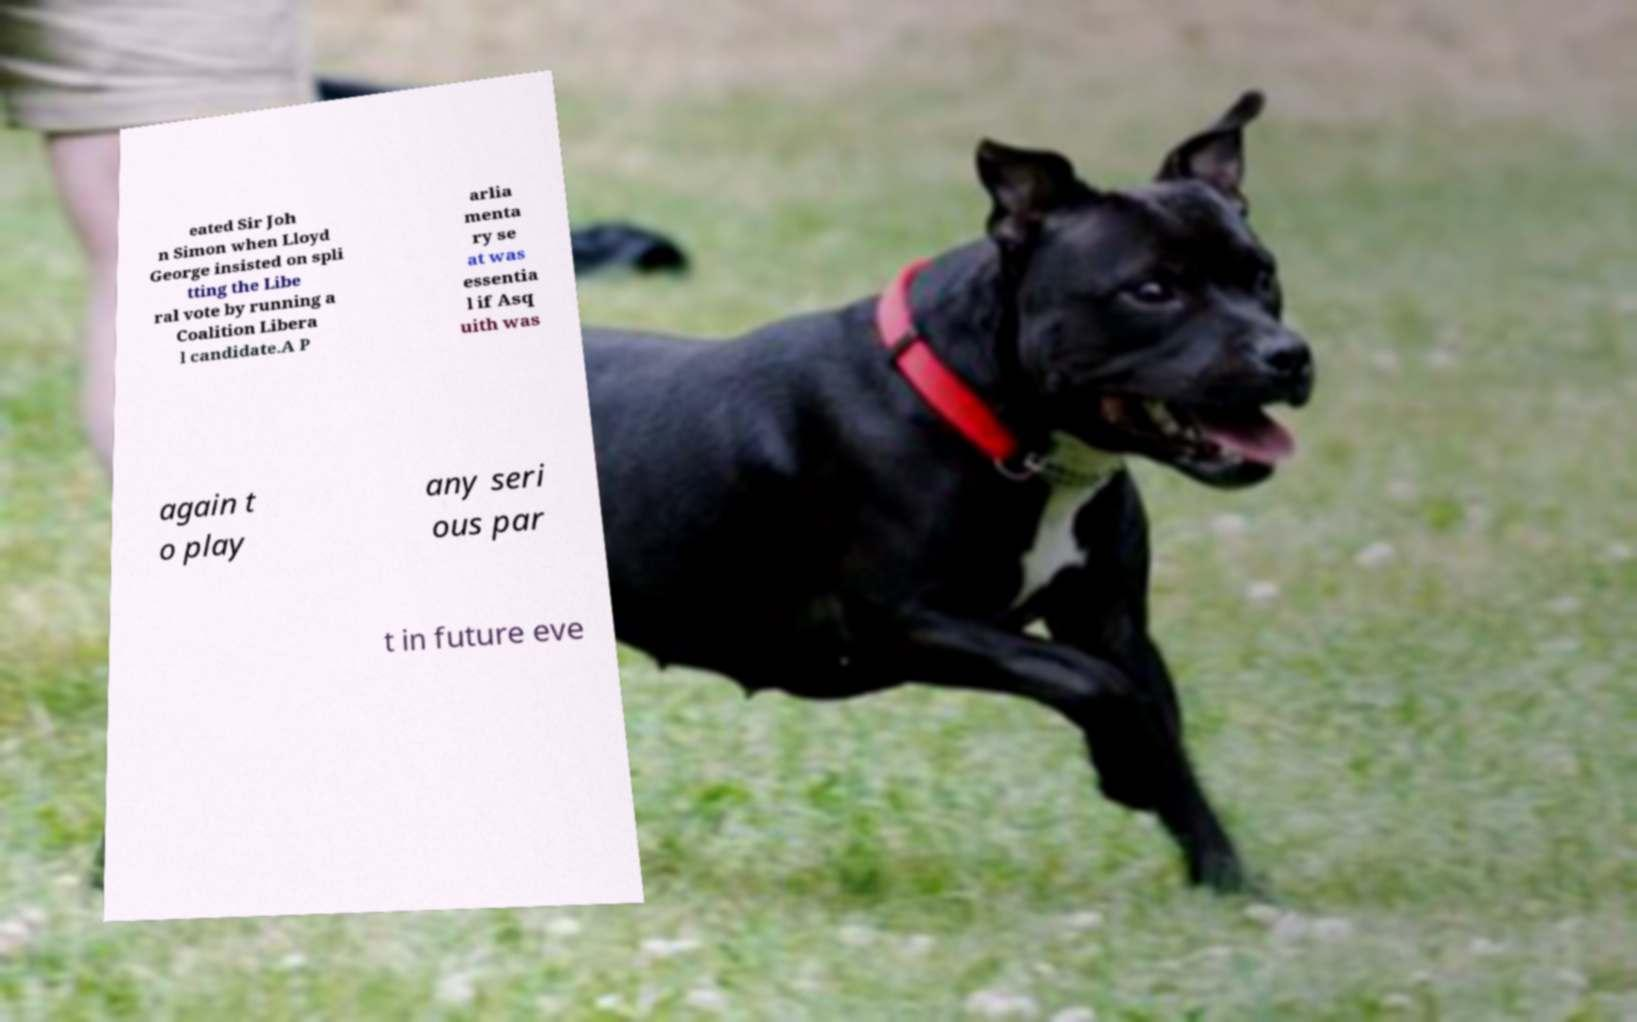Please read and relay the text visible in this image. What does it say? eated Sir Joh n Simon when Lloyd George insisted on spli tting the Libe ral vote by running a Coalition Libera l candidate.A P arlia menta ry se at was essentia l if Asq uith was again t o play any seri ous par t in future eve 